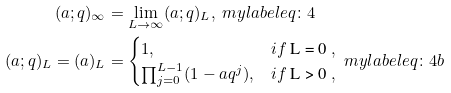Convert formula to latex. <formula><loc_0><loc_0><loc_500><loc_500>( a ; q ) _ { \infty } & = \lim _ { L \to \infty } ( a ; q ) _ { L } , \ m y l a b e l { e q \colon 4 } \\ ( a ; q ) _ { L } = ( a ) _ { L } & = \begin{cases} 1 , & i f $ L = 0 $ , \\ \prod _ { j = 0 } ^ { L - 1 } ( 1 - a q ^ { j } ) , & i f $ L > 0 $ , \end{cases} \ m y l a b e l { e q \colon 4 b }</formula> 